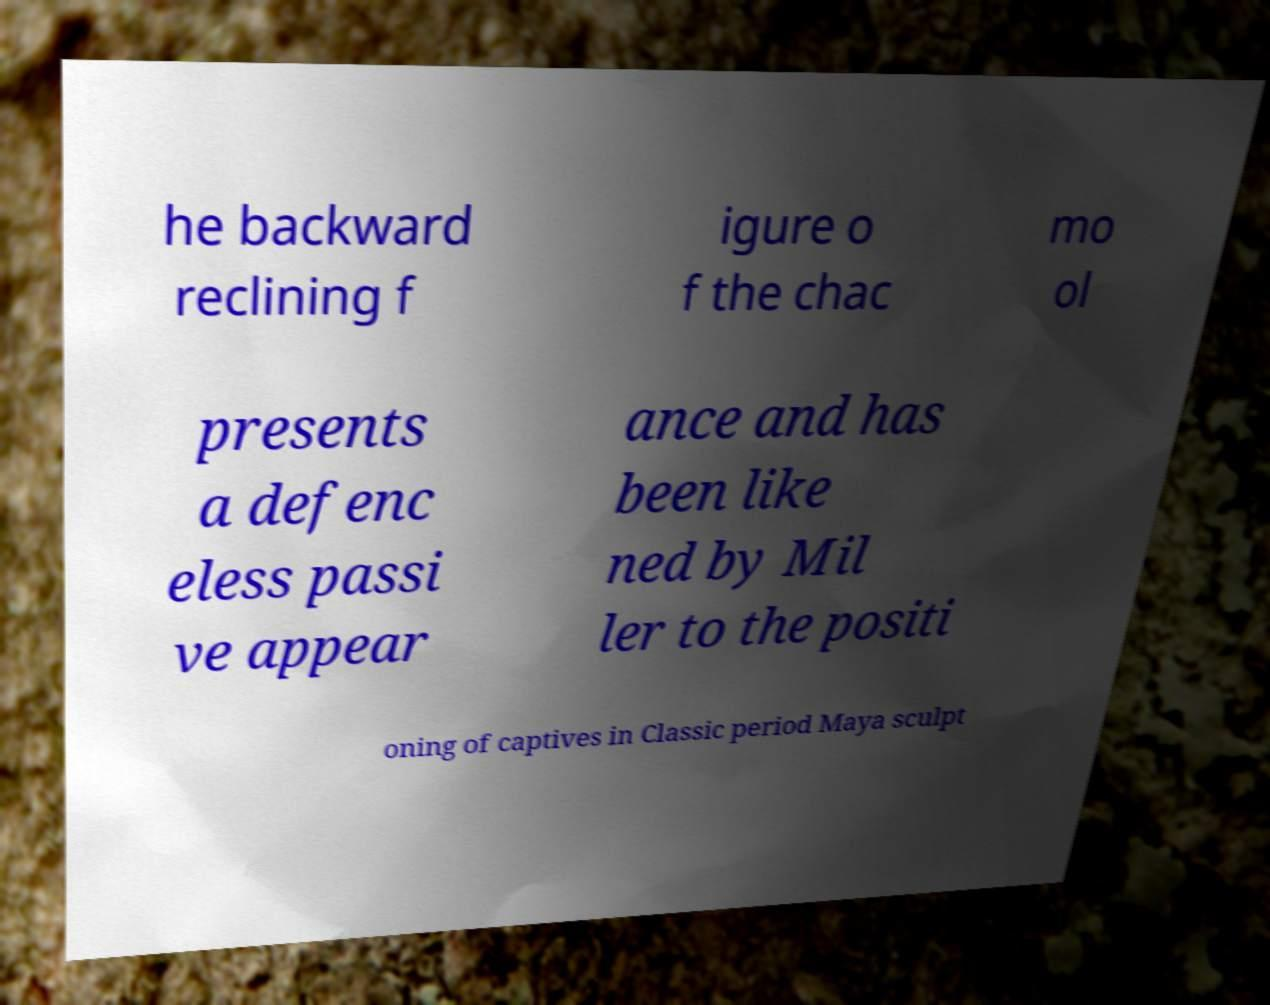I need the written content from this picture converted into text. Can you do that? he backward reclining f igure o f the chac mo ol presents a defenc eless passi ve appear ance and has been like ned by Mil ler to the positi oning of captives in Classic period Maya sculpt 